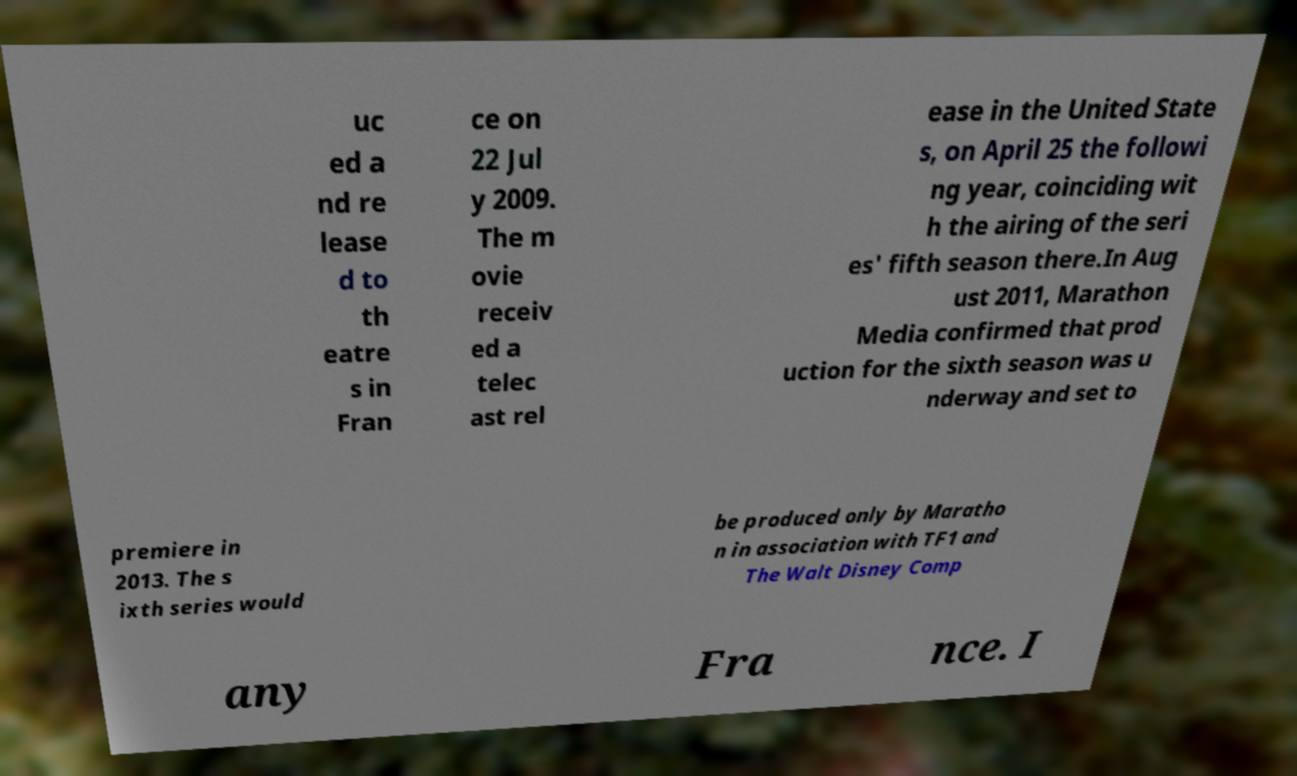What messages or text are displayed in this image? I need them in a readable, typed format. uc ed a nd re lease d to th eatre s in Fran ce on 22 Jul y 2009. The m ovie receiv ed a telec ast rel ease in the United State s, on April 25 the followi ng year, coinciding wit h the airing of the seri es' fifth season there.In Aug ust 2011, Marathon Media confirmed that prod uction for the sixth season was u nderway and set to premiere in 2013. The s ixth series would be produced only by Maratho n in association with TF1 and The Walt Disney Comp any Fra nce. I 